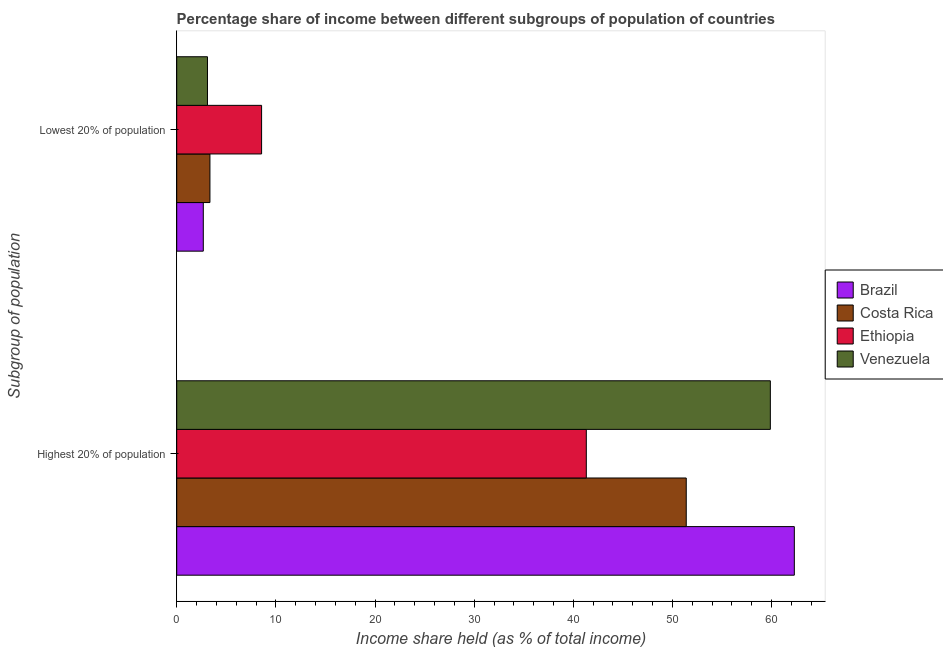Are the number of bars per tick equal to the number of legend labels?
Your answer should be very brief. Yes. How many bars are there on the 1st tick from the bottom?
Your response must be concise. 4. What is the label of the 2nd group of bars from the top?
Ensure brevity in your answer.  Highest 20% of population. What is the income share held by highest 20% of the population in Ethiopia?
Provide a short and direct response. 41.31. Across all countries, what is the maximum income share held by lowest 20% of the population?
Give a very brief answer. 8.56. Across all countries, what is the minimum income share held by highest 20% of the population?
Make the answer very short. 41.31. What is the total income share held by lowest 20% of the population in the graph?
Ensure brevity in your answer.  17.69. What is the difference between the income share held by highest 20% of the population in Ethiopia and that in Brazil?
Your answer should be compact. -20.98. What is the difference between the income share held by highest 20% of the population in Venezuela and the income share held by lowest 20% of the population in Costa Rica?
Offer a very short reply. 56.52. What is the average income share held by highest 20% of the population per country?
Your answer should be compact. 53.72. What is the difference between the income share held by highest 20% of the population and income share held by lowest 20% of the population in Costa Rica?
Provide a short and direct response. 48.04. In how many countries, is the income share held by lowest 20% of the population greater than 2 %?
Your answer should be compact. 4. What is the ratio of the income share held by lowest 20% of the population in Costa Rica to that in Venezuela?
Keep it short and to the point. 1.08. What does the 2nd bar from the bottom in Lowest 20% of population represents?
Your answer should be very brief. Costa Rica. What is the difference between two consecutive major ticks on the X-axis?
Ensure brevity in your answer.  10. Does the graph contain grids?
Provide a succinct answer. No. Where does the legend appear in the graph?
Provide a short and direct response. Center right. How are the legend labels stacked?
Offer a terse response. Vertical. What is the title of the graph?
Provide a short and direct response. Percentage share of income between different subgroups of population of countries. Does "United Kingdom" appear as one of the legend labels in the graph?
Offer a very short reply. No. What is the label or title of the X-axis?
Offer a terse response. Income share held (as % of total income). What is the label or title of the Y-axis?
Give a very brief answer. Subgroup of population. What is the Income share held (as % of total income) in Brazil in Highest 20% of population?
Offer a very short reply. 62.29. What is the Income share held (as % of total income) in Costa Rica in Highest 20% of population?
Your answer should be very brief. 51.39. What is the Income share held (as % of total income) of Ethiopia in Highest 20% of population?
Give a very brief answer. 41.31. What is the Income share held (as % of total income) of Venezuela in Highest 20% of population?
Your response must be concise. 59.87. What is the Income share held (as % of total income) in Brazil in Lowest 20% of population?
Keep it short and to the point. 2.68. What is the Income share held (as % of total income) in Costa Rica in Lowest 20% of population?
Provide a short and direct response. 3.35. What is the Income share held (as % of total income) in Ethiopia in Lowest 20% of population?
Make the answer very short. 8.56. What is the Income share held (as % of total income) of Venezuela in Lowest 20% of population?
Your answer should be compact. 3.1. Across all Subgroup of population, what is the maximum Income share held (as % of total income) of Brazil?
Make the answer very short. 62.29. Across all Subgroup of population, what is the maximum Income share held (as % of total income) in Costa Rica?
Keep it short and to the point. 51.39. Across all Subgroup of population, what is the maximum Income share held (as % of total income) in Ethiopia?
Your answer should be very brief. 41.31. Across all Subgroup of population, what is the maximum Income share held (as % of total income) of Venezuela?
Keep it short and to the point. 59.87. Across all Subgroup of population, what is the minimum Income share held (as % of total income) of Brazil?
Make the answer very short. 2.68. Across all Subgroup of population, what is the minimum Income share held (as % of total income) in Costa Rica?
Give a very brief answer. 3.35. Across all Subgroup of population, what is the minimum Income share held (as % of total income) of Ethiopia?
Your answer should be compact. 8.56. Across all Subgroup of population, what is the minimum Income share held (as % of total income) in Venezuela?
Give a very brief answer. 3.1. What is the total Income share held (as % of total income) in Brazil in the graph?
Your response must be concise. 64.97. What is the total Income share held (as % of total income) of Costa Rica in the graph?
Give a very brief answer. 54.74. What is the total Income share held (as % of total income) of Ethiopia in the graph?
Make the answer very short. 49.87. What is the total Income share held (as % of total income) in Venezuela in the graph?
Give a very brief answer. 62.97. What is the difference between the Income share held (as % of total income) of Brazil in Highest 20% of population and that in Lowest 20% of population?
Provide a short and direct response. 59.61. What is the difference between the Income share held (as % of total income) in Costa Rica in Highest 20% of population and that in Lowest 20% of population?
Offer a terse response. 48.04. What is the difference between the Income share held (as % of total income) in Ethiopia in Highest 20% of population and that in Lowest 20% of population?
Make the answer very short. 32.75. What is the difference between the Income share held (as % of total income) of Venezuela in Highest 20% of population and that in Lowest 20% of population?
Your response must be concise. 56.77. What is the difference between the Income share held (as % of total income) of Brazil in Highest 20% of population and the Income share held (as % of total income) of Costa Rica in Lowest 20% of population?
Offer a very short reply. 58.94. What is the difference between the Income share held (as % of total income) of Brazil in Highest 20% of population and the Income share held (as % of total income) of Ethiopia in Lowest 20% of population?
Your answer should be very brief. 53.73. What is the difference between the Income share held (as % of total income) of Brazil in Highest 20% of population and the Income share held (as % of total income) of Venezuela in Lowest 20% of population?
Offer a terse response. 59.19. What is the difference between the Income share held (as % of total income) in Costa Rica in Highest 20% of population and the Income share held (as % of total income) in Ethiopia in Lowest 20% of population?
Your response must be concise. 42.83. What is the difference between the Income share held (as % of total income) of Costa Rica in Highest 20% of population and the Income share held (as % of total income) of Venezuela in Lowest 20% of population?
Offer a terse response. 48.29. What is the difference between the Income share held (as % of total income) of Ethiopia in Highest 20% of population and the Income share held (as % of total income) of Venezuela in Lowest 20% of population?
Make the answer very short. 38.21. What is the average Income share held (as % of total income) of Brazil per Subgroup of population?
Provide a succinct answer. 32.48. What is the average Income share held (as % of total income) of Costa Rica per Subgroup of population?
Offer a very short reply. 27.37. What is the average Income share held (as % of total income) in Ethiopia per Subgroup of population?
Your answer should be very brief. 24.93. What is the average Income share held (as % of total income) of Venezuela per Subgroup of population?
Your response must be concise. 31.48. What is the difference between the Income share held (as % of total income) of Brazil and Income share held (as % of total income) of Ethiopia in Highest 20% of population?
Provide a short and direct response. 20.98. What is the difference between the Income share held (as % of total income) in Brazil and Income share held (as % of total income) in Venezuela in Highest 20% of population?
Your response must be concise. 2.42. What is the difference between the Income share held (as % of total income) in Costa Rica and Income share held (as % of total income) in Ethiopia in Highest 20% of population?
Give a very brief answer. 10.08. What is the difference between the Income share held (as % of total income) of Costa Rica and Income share held (as % of total income) of Venezuela in Highest 20% of population?
Offer a terse response. -8.48. What is the difference between the Income share held (as % of total income) of Ethiopia and Income share held (as % of total income) of Venezuela in Highest 20% of population?
Offer a very short reply. -18.56. What is the difference between the Income share held (as % of total income) in Brazil and Income share held (as % of total income) in Costa Rica in Lowest 20% of population?
Your response must be concise. -0.67. What is the difference between the Income share held (as % of total income) of Brazil and Income share held (as % of total income) of Ethiopia in Lowest 20% of population?
Your answer should be very brief. -5.88. What is the difference between the Income share held (as % of total income) of Brazil and Income share held (as % of total income) of Venezuela in Lowest 20% of population?
Make the answer very short. -0.42. What is the difference between the Income share held (as % of total income) in Costa Rica and Income share held (as % of total income) in Ethiopia in Lowest 20% of population?
Make the answer very short. -5.21. What is the difference between the Income share held (as % of total income) of Costa Rica and Income share held (as % of total income) of Venezuela in Lowest 20% of population?
Your answer should be very brief. 0.25. What is the difference between the Income share held (as % of total income) in Ethiopia and Income share held (as % of total income) in Venezuela in Lowest 20% of population?
Offer a terse response. 5.46. What is the ratio of the Income share held (as % of total income) of Brazil in Highest 20% of population to that in Lowest 20% of population?
Make the answer very short. 23.24. What is the ratio of the Income share held (as % of total income) in Costa Rica in Highest 20% of population to that in Lowest 20% of population?
Provide a short and direct response. 15.34. What is the ratio of the Income share held (as % of total income) in Ethiopia in Highest 20% of population to that in Lowest 20% of population?
Your answer should be compact. 4.83. What is the ratio of the Income share held (as % of total income) in Venezuela in Highest 20% of population to that in Lowest 20% of population?
Provide a succinct answer. 19.31. What is the difference between the highest and the second highest Income share held (as % of total income) of Brazil?
Give a very brief answer. 59.61. What is the difference between the highest and the second highest Income share held (as % of total income) of Costa Rica?
Your response must be concise. 48.04. What is the difference between the highest and the second highest Income share held (as % of total income) in Ethiopia?
Offer a very short reply. 32.75. What is the difference between the highest and the second highest Income share held (as % of total income) of Venezuela?
Provide a short and direct response. 56.77. What is the difference between the highest and the lowest Income share held (as % of total income) of Brazil?
Your answer should be compact. 59.61. What is the difference between the highest and the lowest Income share held (as % of total income) of Costa Rica?
Make the answer very short. 48.04. What is the difference between the highest and the lowest Income share held (as % of total income) of Ethiopia?
Provide a short and direct response. 32.75. What is the difference between the highest and the lowest Income share held (as % of total income) in Venezuela?
Keep it short and to the point. 56.77. 